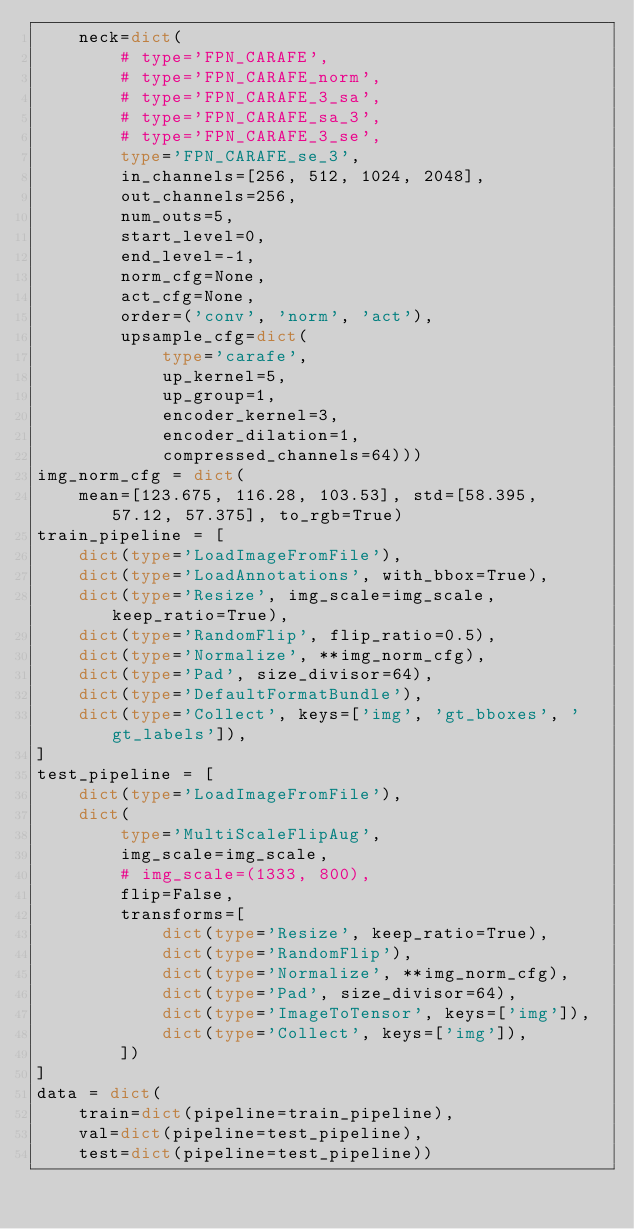<code> <loc_0><loc_0><loc_500><loc_500><_Python_>    neck=dict(
        # type='FPN_CARAFE',
        # type='FPN_CARAFE_norm',
        # type='FPN_CARAFE_3_sa',
        # type='FPN_CARAFE_sa_3',
        # type='FPN_CARAFE_3_se',
        type='FPN_CARAFE_se_3',
        in_channels=[256, 512, 1024, 2048],
        out_channels=256,
        num_outs=5,
        start_level=0,
        end_level=-1,
        norm_cfg=None,
        act_cfg=None,
        order=('conv', 'norm', 'act'),
        upsample_cfg=dict(
            type='carafe',
            up_kernel=5,
            up_group=1,
            encoder_kernel=3,
            encoder_dilation=1,
            compressed_channels=64)))
img_norm_cfg = dict(
    mean=[123.675, 116.28, 103.53], std=[58.395, 57.12, 57.375], to_rgb=True)
train_pipeline = [
    dict(type='LoadImageFromFile'),
    dict(type='LoadAnnotations', with_bbox=True),
    dict(type='Resize', img_scale=img_scale, keep_ratio=True),
    dict(type='RandomFlip', flip_ratio=0.5),
    dict(type='Normalize', **img_norm_cfg),
    dict(type='Pad', size_divisor=64),
    dict(type='DefaultFormatBundle'),
    dict(type='Collect', keys=['img', 'gt_bboxes', 'gt_labels']),
]
test_pipeline = [
    dict(type='LoadImageFromFile'),
    dict(
        type='MultiScaleFlipAug',
        img_scale=img_scale,
        # img_scale=(1333, 800),
        flip=False,
        transforms=[
            dict(type='Resize', keep_ratio=True),
            dict(type='RandomFlip'),
            dict(type='Normalize', **img_norm_cfg),
            dict(type='Pad', size_divisor=64),
            dict(type='ImageToTensor', keys=['img']),
            dict(type='Collect', keys=['img']),
        ])
]
data = dict(
    train=dict(pipeline=train_pipeline),
    val=dict(pipeline=test_pipeline),
    test=dict(pipeline=test_pipeline))
</code> 